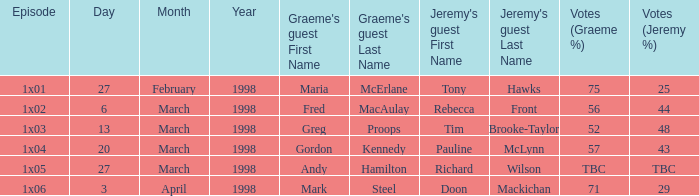What is Jeremy's Guest, when First Broadcast is "20 March 1998"? Pauline McLynn. 